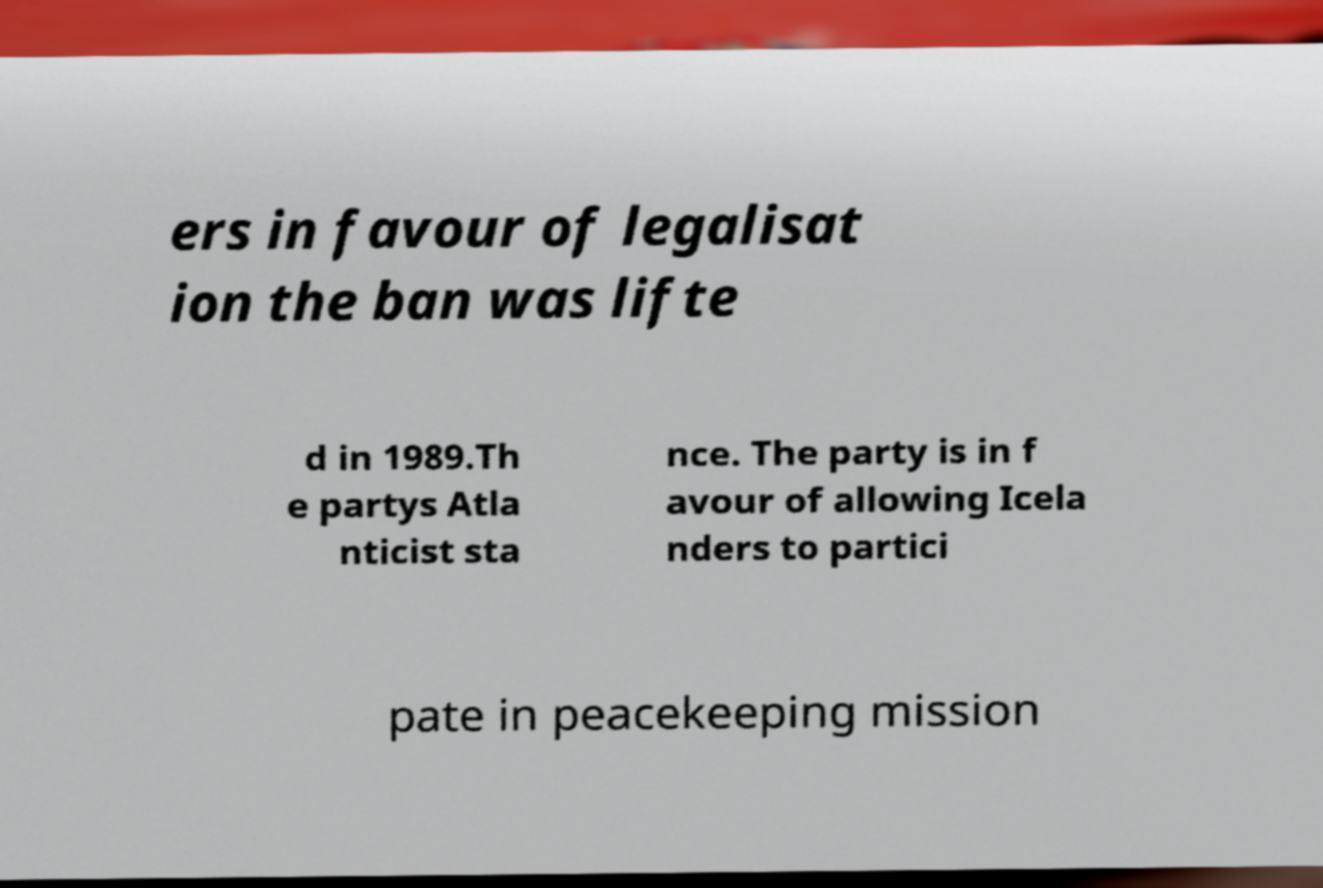What messages or text are displayed in this image? I need them in a readable, typed format. ers in favour of legalisat ion the ban was lifte d in 1989.Th e partys Atla nticist sta nce. The party is in f avour of allowing Icela nders to partici pate in peacekeeping mission 